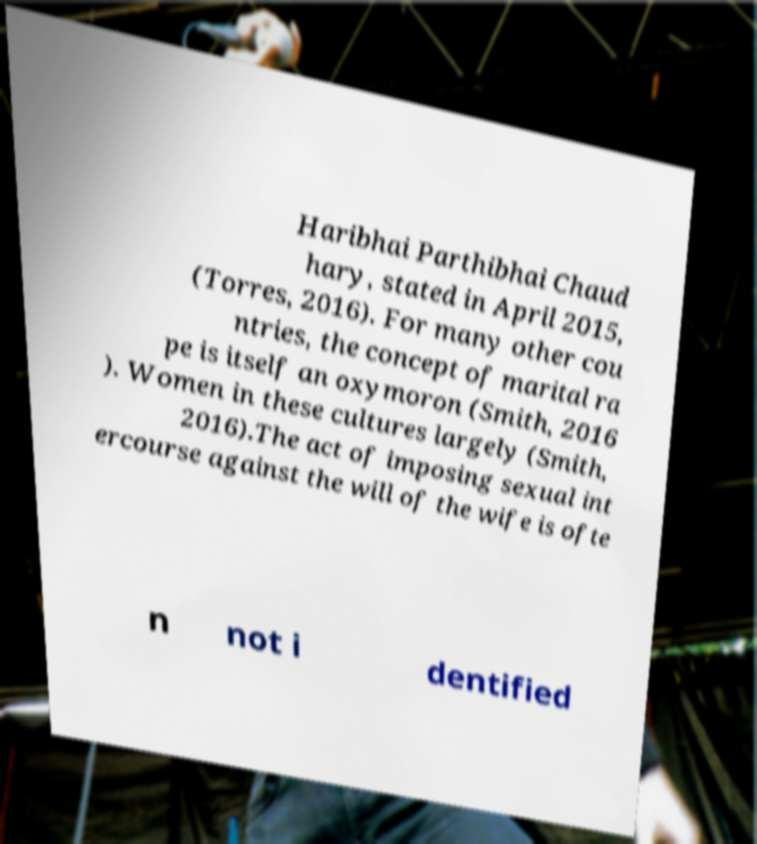For documentation purposes, I need the text within this image transcribed. Could you provide that? Haribhai Parthibhai Chaud hary, stated in April 2015, (Torres, 2016). For many other cou ntries, the concept of marital ra pe is itself an oxymoron (Smith, 2016 ). Women in these cultures largely (Smith, 2016).The act of imposing sexual int ercourse against the will of the wife is ofte n not i dentified 